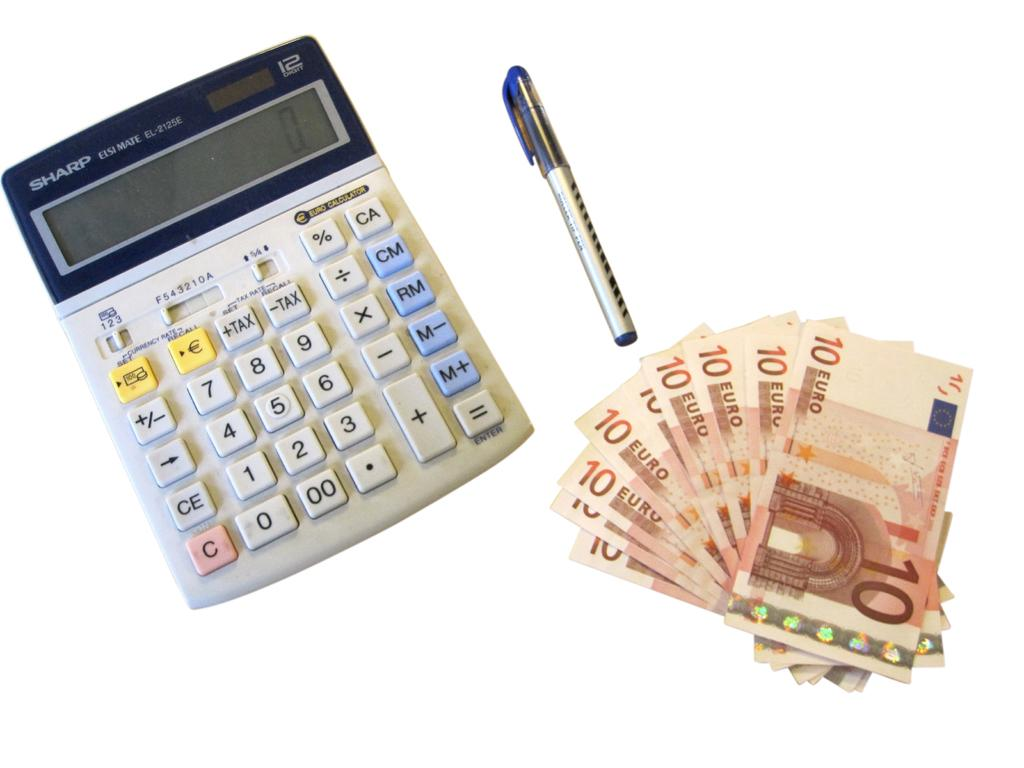Provide a one-sentence caption for the provided image. On the calculator the number 2 is to the right of the number 1. 